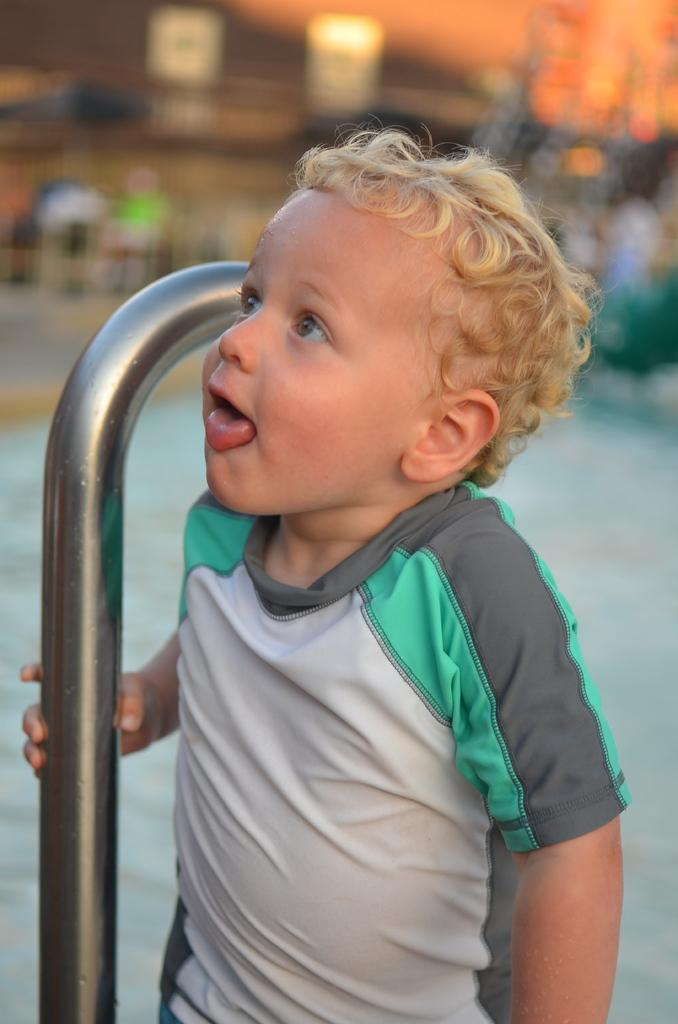Who is present in the image? There is a boy in the image. What is the boy doing in the image? The boy is standing in the image. What object is the boy holding in the image? The boy is holding a metal rod in the image. What can be seen in the background of the image? There is water visible in the image. What type of card is the boy holding in the image? There is no card present in the image; the boy is holding a metal rod. What kind of office furniture can be seen in the image? There is no office furniture present in the image; it features a boy standing with a metal rod and water in the background. 